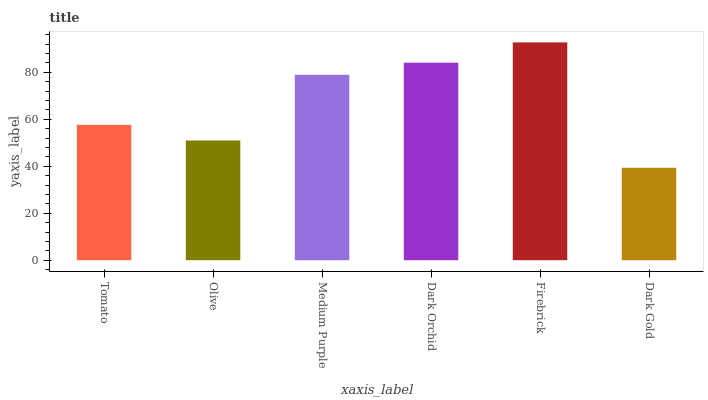Is Olive the minimum?
Answer yes or no. No. Is Olive the maximum?
Answer yes or no. No. Is Tomato greater than Olive?
Answer yes or no. Yes. Is Olive less than Tomato?
Answer yes or no. Yes. Is Olive greater than Tomato?
Answer yes or no. No. Is Tomato less than Olive?
Answer yes or no. No. Is Medium Purple the high median?
Answer yes or no. Yes. Is Tomato the low median?
Answer yes or no. Yes. Is Dark Orchid the high median?
Answer yes or no. No. Is Medium Purple the low median?
Answer yes or no. No. 